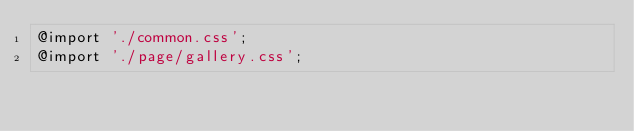Convert code to text. <code><loc_0><loc_0><loc_500><loc_500><_CSS_>@import './common.css';
@import './page/gallery.css';</code> 